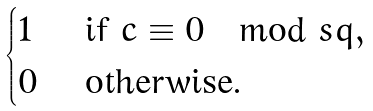<formula> <loc_0><loc_0><loc_500><loc_500>\begin{cases} 1 & \text { if } c \equiv 0 \mod s { q } , \\ 0 & \text { otherwise.} \end{cases}</formula> 